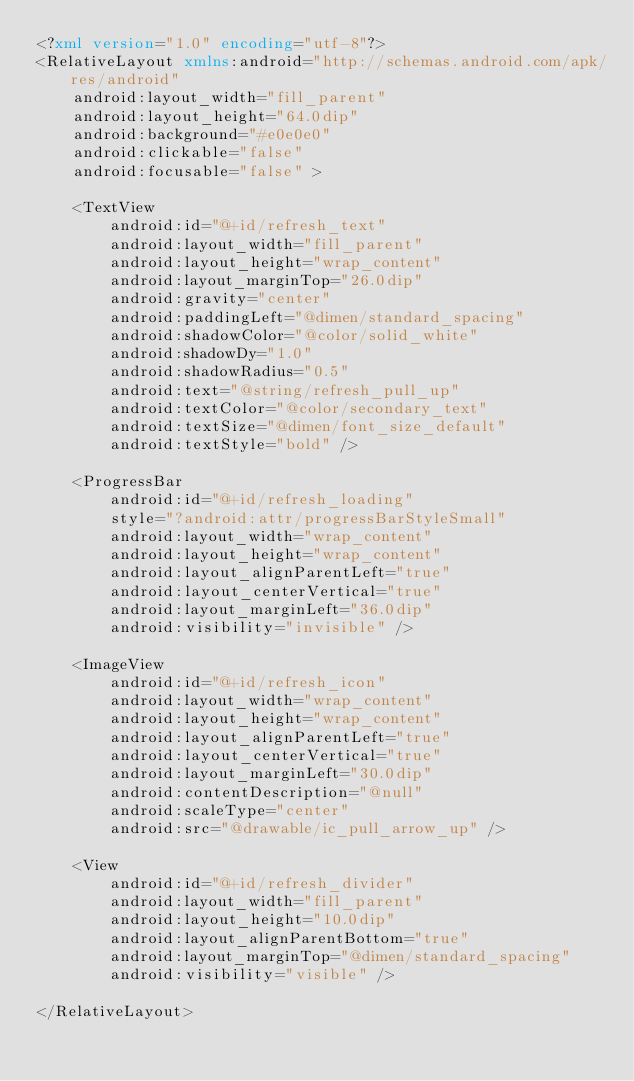<code> <loc_0><loc_0><loc_500><loc_500><_XML_><?xml version="1.0" encoding="utf-8"?>
<RelativeLayout xmlns:android="http://schemas.android.com/apk/res/android"
    android:layout_width="fill_parent"
    android:layout_height="64.0dip"
    android:background="#e0e0e0"
    android:clickable="false"
    android:focusable="false" >

    <TextView
        android:id="@+id/refresh_text"
        android:layout_width="fill_parent"
        android:layout_height="wrap_content"
        android:layout_marginTop="26.0dip"
        android:gravity="center"
        android:paddingLeft="@dimen/standard_spacing"
        android:shadowColor="@color/solid_white"
        android:shadowDy="1.0"
        android:shadowRadius="0.5"
        android:text="@string/refresh_pull_up"
        android:textColor="@color/secondary_text"
        android:textSize="@dimen/font_size_default"
        android:textStyle="bold" />

    <ProgressBar
        android:id="@+id/refresh_loading"
        style="?android:attr/progressBarStyleSmall"
        android:layout_width="wrap_content"
        android:layout_height="wrap_content"
        android:layout_alignParentLeft="true"
        android:layout_centerVertical="true"
        android:layout_marginLeft="36.0dip"
        android:visibility="invisible" />

    <ImageView
        android:id="@+id/refresh_icon"
        android:layout_width="wrap_content"
        android:layout_height="wrap_content"
        android:layout_alignParentLeft="true"
        android:layout_centerVertical="true"
        android:layout_marginLeft="30.0dip"
        android:contentDescription="@null"
        android:scaleType="center"
        android:src="@drawable/ic_pull_arrow_up" />

    <View
        android:id="@+id/refresh_divider"
        android:layout_width="fill_parent"
        android:layout_height="10.0dip"
        android:layout_alignParentBottom="true"
        android:layout_marginTop="@dimen/standard_spacing"
        android:visibility="visible" />

</RelativeLayout></code> 